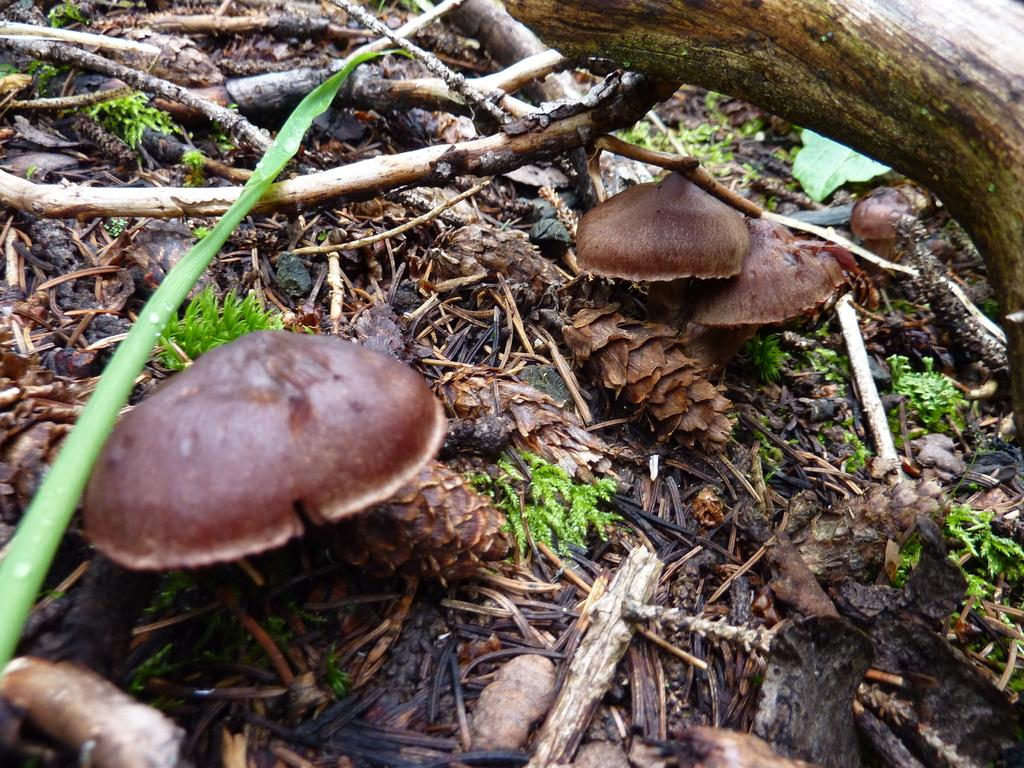What type of fungi can be seen in the image? There are mushrooms in the image. What material are some of the objects made of in the image? There are wooden pieces in the image. What type of vegetation is present in the image? There are plants in the image. What part of a plant can be seen in the image? There is a leaf in the image. Can you see any fairies interacting with the mushrooms in the image? There are no fairies present in the image; it only features mushrooms, wooden pieces, plants, and a leaf. What type of pipe is visible in the image? There is no pipe present in the image. 